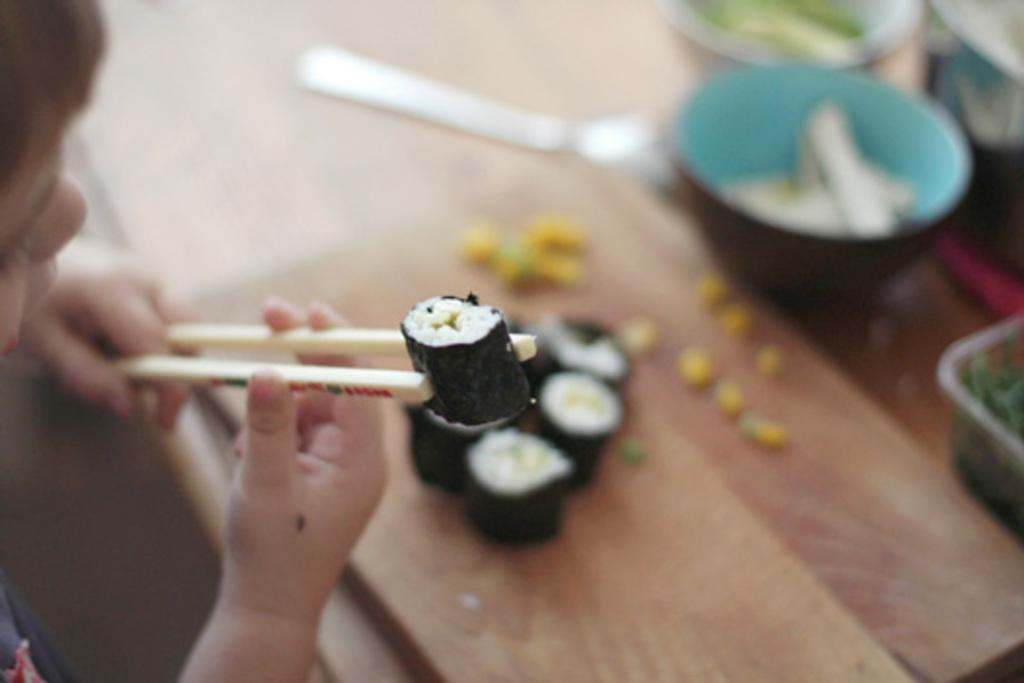Who is in the image? There is a boy in the image. What is the boy holding in the image? The boy is holding chopsticks. What type of food can be seen in the image? There is sushi, a Japanese food, in the image. What other objects are visible in the background of the image? There is a bowl and a spoon on the table in the background of the image. What holiday is being celebrated in the image? There is no indication of a holiday being celebrated in the image. The image features a boy holding chopsticks and sushi, but no holiday-related elements are present. 